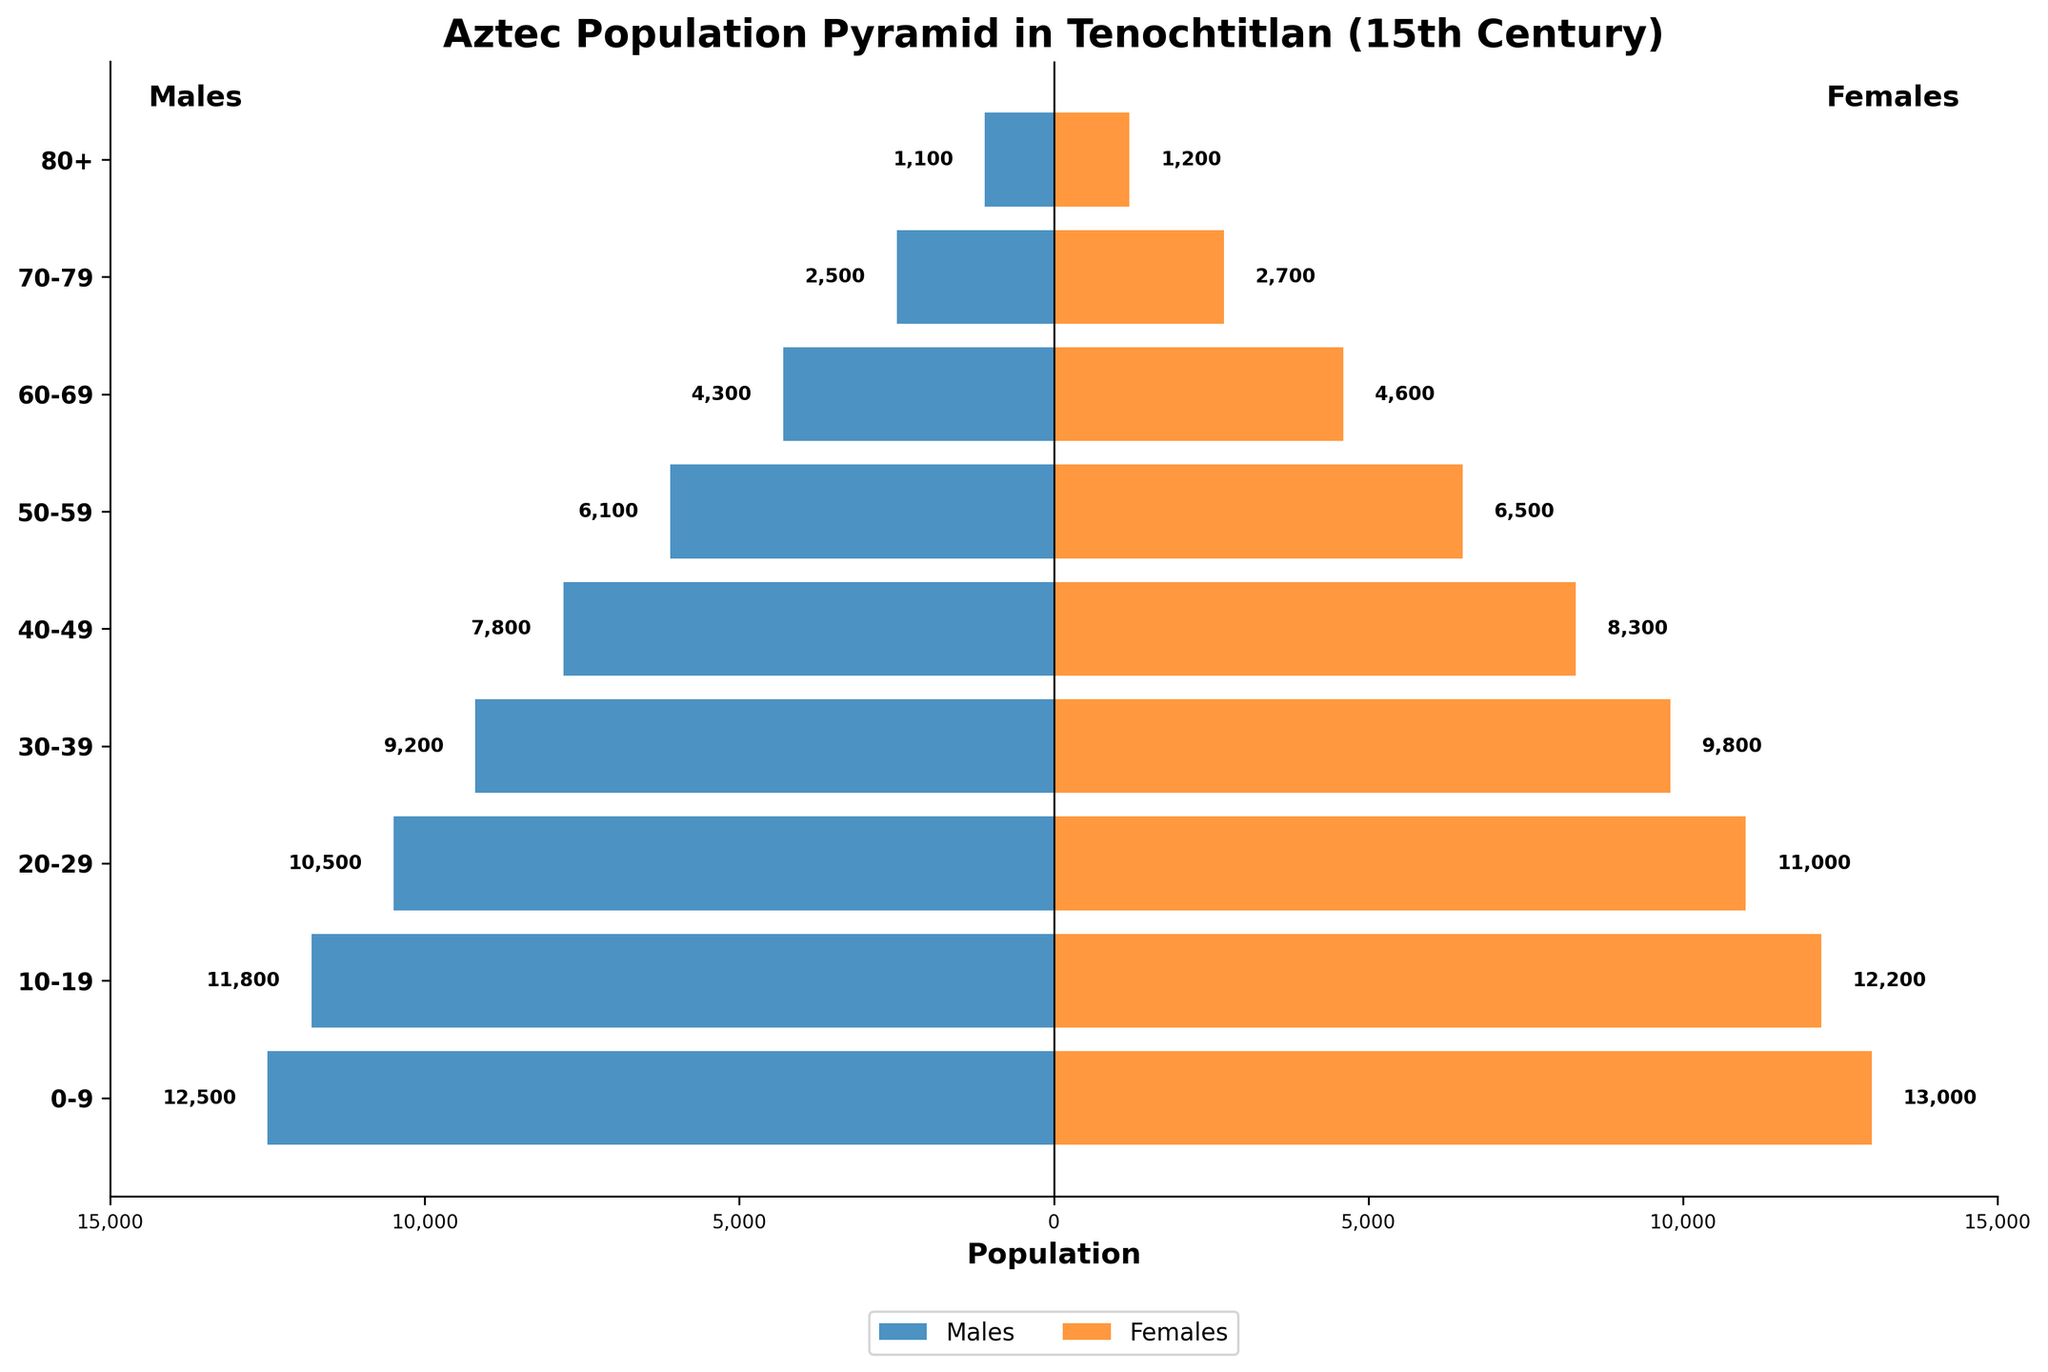How does the population of males compare to females in the age group 20-29? Look at the horizontal bars corresponding to the age group 20-29. The length of the males' bar is 10,500, and the length of the females' bar is 11,000. Therefore, females are more numerous by 500 in that age group.
Answer: Females outnumber males by 500 What is the total population of the age group 40-49? Sum the populations of both males and females in the age group 40-49. Males are 7,800 and females are 8,300. Therefore, the total is 7,800 + 8,300 = 16,100.
Answer: 16,100 Which age group has the smallest population, and what is the gender distribution? Identify the shortest bars in the pyramid. The age group 80+ has the smallest population. The bars show 1,100 males and 1,200 females.
Answer: 80+ with 1,100 males and 1,200 females What is the most populous age group? Look for the longest horizontal bars in the pyramid. The age group 0-9 is the longest, indicating it is the most populous.
Answer: 0-9 How does the population of females change from the age group 0-9 to 10-19? Inspect the bars for females in the age groups 0-9 and 10-19. The population for females in 0-9 is 13,000, and in 10-19, it is 12,200. The population decreases by 13,000 - 12,200 = 800.
Answer: Decreases by 800 What is the combined population of all males across all age groups? Add the populations of males across all age groups. The sums are: 12,500 + 11,800 + 10,500 + 9,200 + 7,800 + 6,100 + 4,300 + 2,500 + 1,100 = 65,800.
Answer: 65,800 Is there a significant gender difference in the age group 70-79? Compare the population bars for males and females in the age group 70-79. The values are 2,500 males and 2,700 females, which shows a small difference of 200.
Answer: No significant difference, females outnumber males by 200 What percentage of the total female population are in the age group 20-29? First, find the total population of females across all age groups: 13,000 + 12,200 + 11,000 + 9,800 + 8,300 + 6,500 + 4,600 + 2,700 + 1,200 = 69,300. Then, the population of females in 20-29 is 11,000. Finally, calculate the percentage: (11,000 / 69,300) * 100 = 15.87%.
Answer: 15.87% How does the overall population trend with age? Observe the lengths of the bars from the youngest age group (0-9) to the oldest (80+). The bars consistently decrease in length as the age groups increase.
Answer: Decreases with age Are there any age groups where the male population is greater than the female population? Compare the lengths of the male and female bars across all age groups. In all age groups, the female population is slightly higher or equal.
Answer: No 